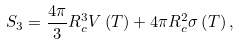<formula> <loc_0><loc_0><loc_500><loc_500>S _ { 3 } = \frac { 4 \pi } { 3 } R _ { c } ^ { 3 } V \left ( T \right ) + 4 \pi R _ { c } ^ { 2 } \sigma \left ( T \right ) ,</formula> 